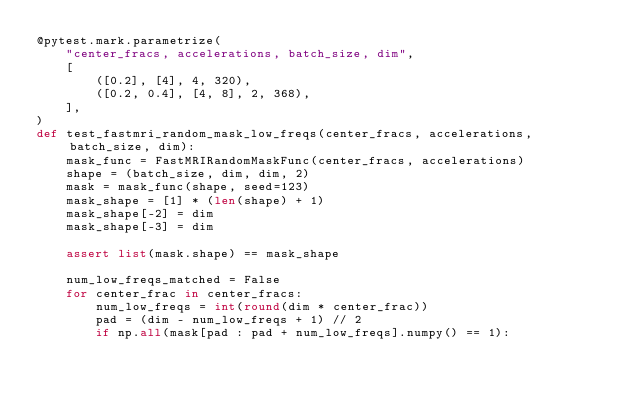<code> <loc_0><loc_0><loc_500><loc_500><_Python_>@pytest.mark.parametrize(
    "center_fracs, accelerations, batch_size, dim",
    [
        ([0.2], [4], 4, 320),
        ([0.2, 0.4], [4, 8], 2, 368),
    ],
)
def test_fastmri_random_mask_low_freqs(center_fracs, accelerations, batch_size, dim):
    mask_func = FastMRIRandomMaskFunc(center_fracs, accelerations)
    shape = (batch_size, dim, dim, 2)
    mask = mask_func(shape, seed=123)
    mask_shape = [1] * (len(shape) + 1)
    mask_shape[-2] = dim
    mask_shape[-3] = dim

    assert list(mask.shape) == mask_shape

    num_low_freqs_matched = False
    for center_frac in center_fracs:
        num_low_freqs = int(round(dim * center_frac))
        pad = (dim - num_low_freqs + 1) // 2
        if np.all(mask[pad : pad + num_low_freqs].numpy() == 1):</code> 